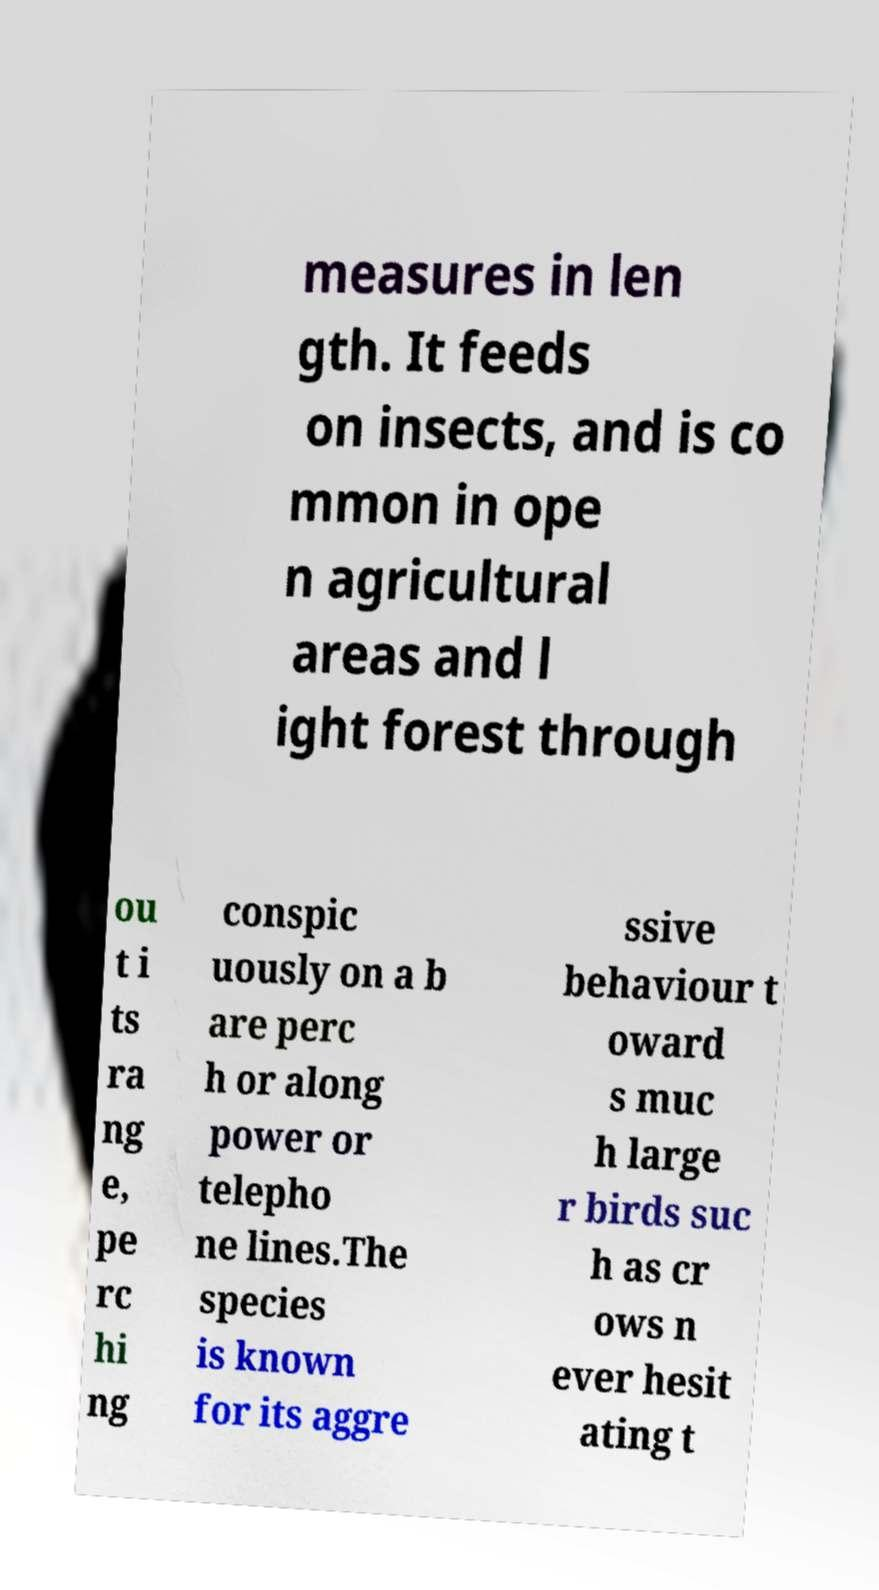I need the written content from this picture converted into text. Can you do that? measures in len gth. It feeds on insects, and is co mmon in ope n agricultural areas and l ight forest through ou t i ts ra ng e, pe rc hi ng conspic uously on a b are perc h or along power or telepho ne lines.The species is known for its aggre ssive behaviour t oward s muc h large r birds suc h as cr ows n ever hesit ating t 